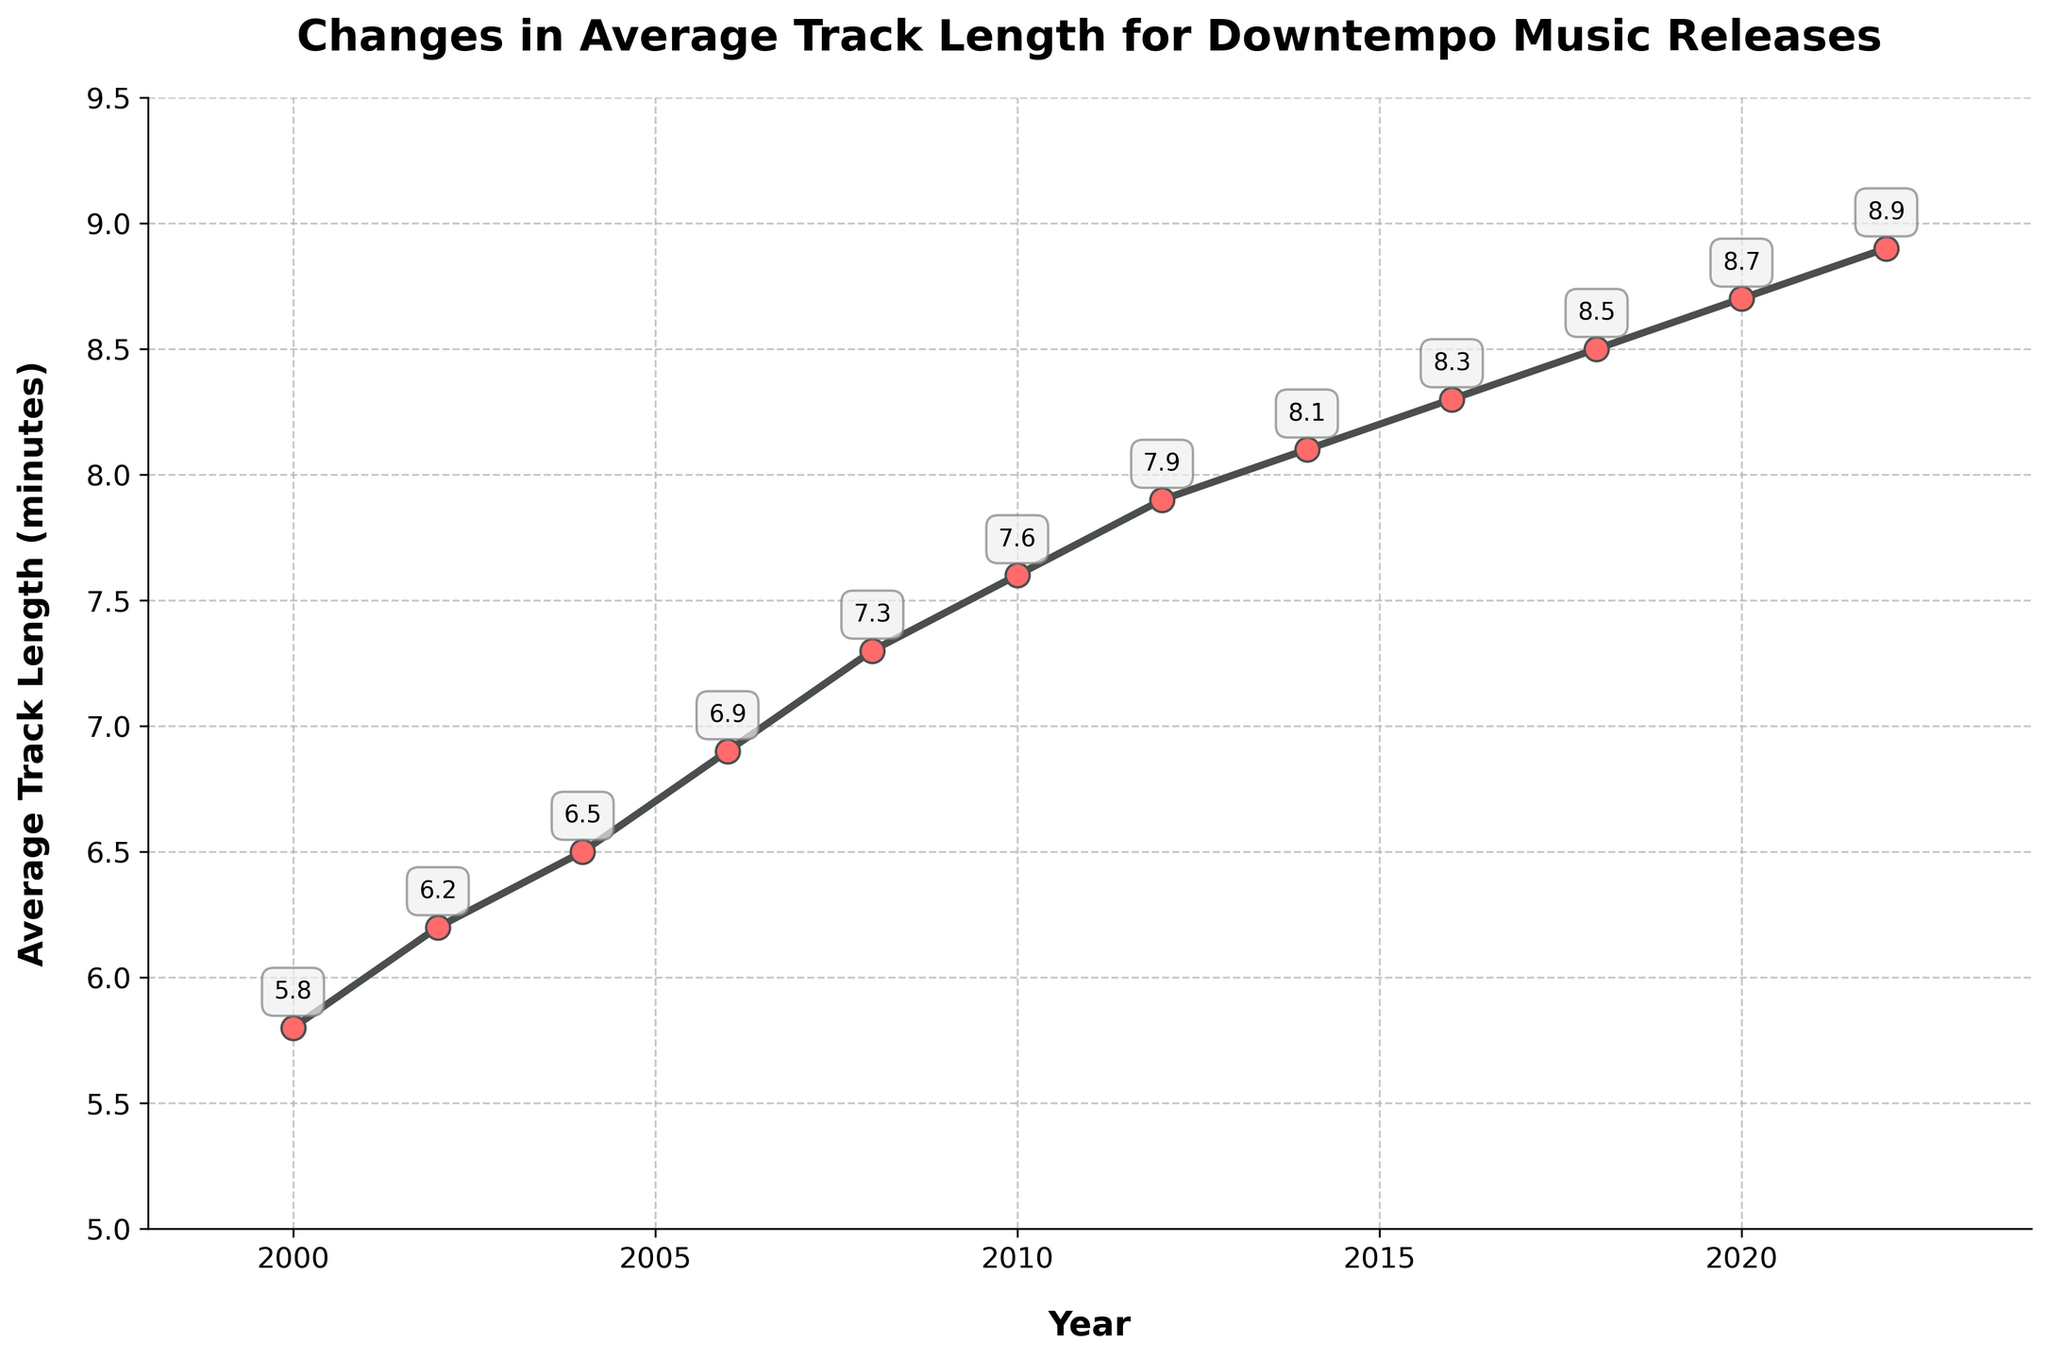Which year saw the highest average track length for downtempo music releases? From the figure, we can see that the point for the year 2022 is the highest, with an average track length of 8.9 minutes.
Answer: 2022 How has the average track length changed from 2000 to 2022? By looking at the start and end points in the figure, the average track length increased from 5.8 minutes in 2000 to 8.9 minutes in 2022.
Answer: Increased by 3.1 minutes What is the average track length for downtempo music in 2010? The point corresponding to the year 2010 in the figure shows an average track length of 7.6 minutes.
Answer: 7.6 minutes Between which consecutive years did the average track length increase the most? By comparing the differences in average track length between consecutive years: 
- 2000 to 2002: 0.4 
- 2002 to 2004: 0.3 
- 2004 to 2006: 0.4 
- 2006 to 2008: 0.4 
- 2008 to 2010: 0.3 
- 2010 to 2012: 0.3 
- 2012 to 2014: 0.2 
- 2014 to 2016: 0.2 
- 2016 to 2018: 0.2 
- 2018 to 2020: 0.2 
- 2020 to 2022: 0.2
The largest increase occurred between 2000 to 2002, 2004 to 2006, and 2006 to 2008, all with an increase of 0.4 minutes.
Answer: 2000 to 2002, 2004 to 2006, 2006 to 2008 What's the difference in average track length between 2008 and 2012? The average track length in 2008 is 7.3 minutes and in 2012 it is 7.9 minutes, so the difference is 7.9 - 7.3 = 0.6 minutes.
Answer: 0.6 minutes Which year had a higher average track length: 2006 or 2014? The average track length for 2006 is 6.9 minutes and for 2014 is 8.1 minutes, so 2014 had a higher average track length.
Answer: 2014 What trend can be observed in the average track lengths from 2000 to 2022? Examining the curve and points in the figure, there's a consistent upwards trend in average track length, increasing over the years.
Answer: Upwards trend What is the range of average track lengths observed in the data? The minimum average track length is 5.8 minutes (in 2000), and the maximum is 8.9 minutes (in 2022), so the range is 8.9 - 5.8 = 3.1 minutes.
Answer: 3.1 minutes Between 2010 and 2022, by how many minutes did the average track length increase? The average track length in 2010 is 7.6 minutes, and in 2022 it is 8.9 minutes. The increase is 8.9 - 7.6 = 1.3 minutes.
Answer: 1.3 minutes 